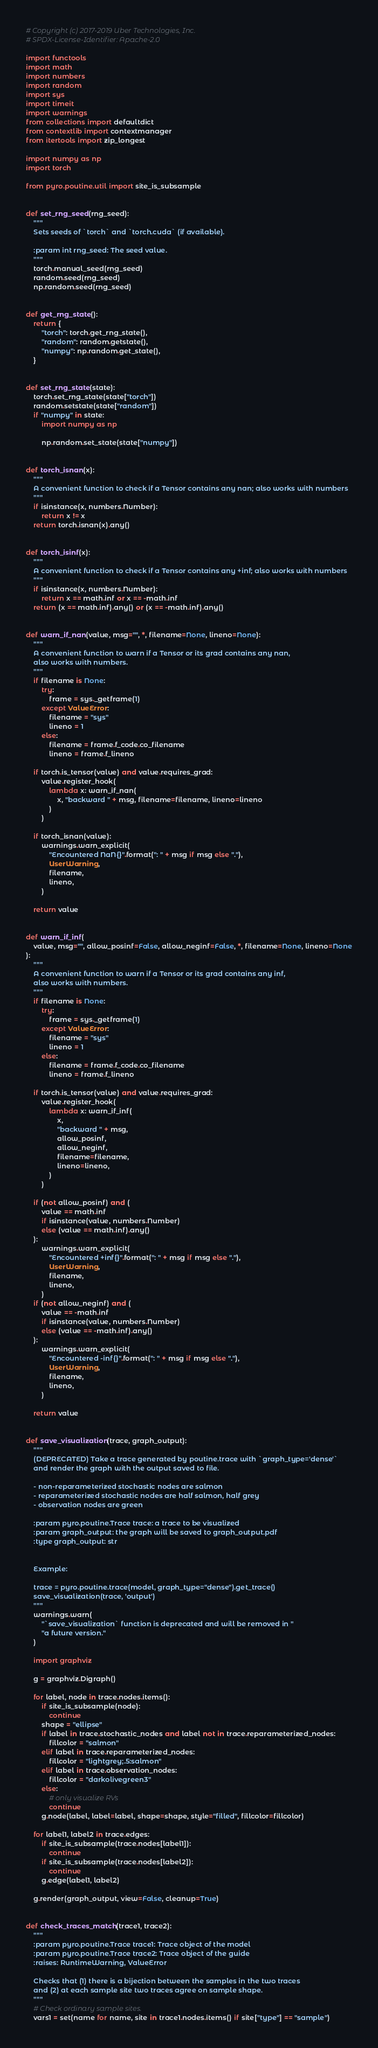Convert code to text. <code><loc_0><loc_0><loc_500><loc_500><_Python_># Copyright (c) 2017-2019 Uber Technologies, Inc.
# SPDX-License-Identifier: Apache-2.0

import functools
import math
import numbers
import random
import sys
import timeit
import warnings
from collections import defaultdict
from contextlib import contextmanager
from itertools import zip_longest

import numpy as np
import torch

from pyro.poutine.util import site_is_subsample


def set_rng_seed(rng_seed):
    """
    Sets seeds of `torch` and `torch.cuda` (if available).

    :param int rng_seed: The seed value.
    """
    torch.manual_seed(rng_seed)
    random.seed(rng_seed)
    np.random.seed(rng_seed)


def get_rng_state():
    return {
        "torch": torch.get_rng_state(),
        "random": random.getstate(),
        "numpy": np.random.get_state(),
    }


def set_rng_state(state):
    torch.set_rng_state(state["torch"])
    random.setstate(state["random"])
    if "numpy" in state:
        import numpy as np

        np.random.set_state(state["numpy"])


def torch_isnan(x):
    """
    A convenient function to check if a Tensor contains any nan; also works with numbers
    """
    if isinstance(x, numbers.Number):
        return x != x
    return torch.isnan(x).any()


def torch_isinf(x):
    """
    A convenient function to check if a Tensor contains any +inf; also works with numbers
    """
    if isinstance(x, numbers.Number):
        return x == math.inf or x == -math.inf
    return (x == math.inf).any() or (x == -math.inf).any()


def warn_if_nan(value, msg="", *, filename=None, lineno=None):
    """
    A convenient function to warn if a Tensor or its grad contains any nan,
    also works with numbers.
    """
    if filename is None:
        try:
            frame = sys._getframe(1)
        except ValueError:
            filename = "sys"
            lineno = 1
        else:
            filename = frame.f_code.co_filename
            lineno = frame.f_lineno

    if torch.is_tensor(value) and value.requires_grad:
        value.register_hook(
            lambda x: warn_if_nan(
                x, "backward " + msg, filename=filename, lineno=lineno
            )
        )

    if torch_isnan(value):
        warnings.warn_explicit(
            "Encountered NaN{}".format(": " + msg if msg else "."),
            UserWarning,
            filename,
            lineno,
        )

    return value


def warn_if_inf(
    value, msg="", allow_posinf=False, allow_neginf=False, *, filename=None, lineno=None
):
    """
    A convenient function to warn if a Tensor or its grad contains any inf,
    also works with numbers.
    """
    if filename is None:
        try:
            frame = sys._getframe(1)
        except ValueError:
            filename = "sys"
            lineno = 1
        else:
            filename = frame.f_code.co_filename
            lineno = frame.f_lineno

    if torch.is_tensor(value) and value.requires_grad:
        value.register_hook(
            lambda x: warn_if_inf(
                x,
                "backward " + msg,
                allow_posinf,
                allow_neginf,
                filename=filename,
                lineno=lineno,
            )
        )

    if (not allow_posinf) and (
        value == math.inf
        if isinstance(value, numbers.Number)
        else (value == math.inf).any()
    ):
        warnings.warn_explicit(
            "Encountered +inf{}".format(": " + msg if msg else "."),
            UserWarning,
            filename,
            lineno,
        )
    if (not allow_neginf) and (
        value == -math.inf
        if isinstance(value, numbers.Number)
        else (value == -math.inf).any()
    ):
        warnings.warn_explicit(
            "Encountered -inf{}".format(": " + msg if msg else "."),
            UserWarning,
            filename,
            lineno,
        )

    return value


def save_visualization(trace, graph_output):
    """
    (DEPRECATED) Take a trace generated by poutine.trace with `graph_type='dense'`
    and render the graph with the output saved to file.

    - non-reparameterized stochastic nodes are salmon
    - reparameterized stochastic nodes are half salmon, half grey
    - observation nodes are green

    :param pyro.poutine.Trace trace: a trace to be visualized
    :param graph_output: the graph will be saved to graph_output.pdf
    :type graph_output: str


    Example:

    trace = pyro.poutine.trace(model, graph_type="dense").get_trace()
    save_visualization(trace, 'output')
    """
    warnings.warn(
        "`save_visualization` function is deprecated and will be removed in "
        "a future version."
    )

    import graphviz

    g = graphviz.Digraph()

    for label, node in trace.nodes.items():
        if site_is_subsample(node):
            continue
        shape = "ellipse"
        if label in trace.stochastic_nodes and label not in trace.reparameterized_nodes:
            fillcolor = "salmon"
        elif label in trace.reparameterized_nodes:
            fillcolor = "lightgrey;.5:salmon"
        elif label in trace.observation_nodes:
            fillcolor = "darkolivegreen3"
        else:
            # only visualize RVs
            continue
        g.node(label, label=label, shape=shape, style="filled", fillcolor=fillcolor)

    for label1, label2 in trace.edges:
        if site_is_subsample(trace.nodes[label1]):
            continue
        if site_is_subsample(trace.nodes[label2]):
            continue
        g.edge(label1, label2)

    g.render(graph_output, view=False, cleanup=True)


def check_traces_match(trace1, trace2):
    """
    :param pyro.poutine.Trace trace1: Trace object of the model
    :param pyro.poutine.Trace trace2: Trace object of the guide
    :raises: RuntimeWarning, ValueError

    Checks that (1) there is a bijection between the samples in the two traces
    and (2) at each sample site two traces agree on sample shape.
    """
    # Check ordinary sample sites.
    vars1 = set(name for name, site in trace1.nodes.items() if site["type"] == "sample")</code> 